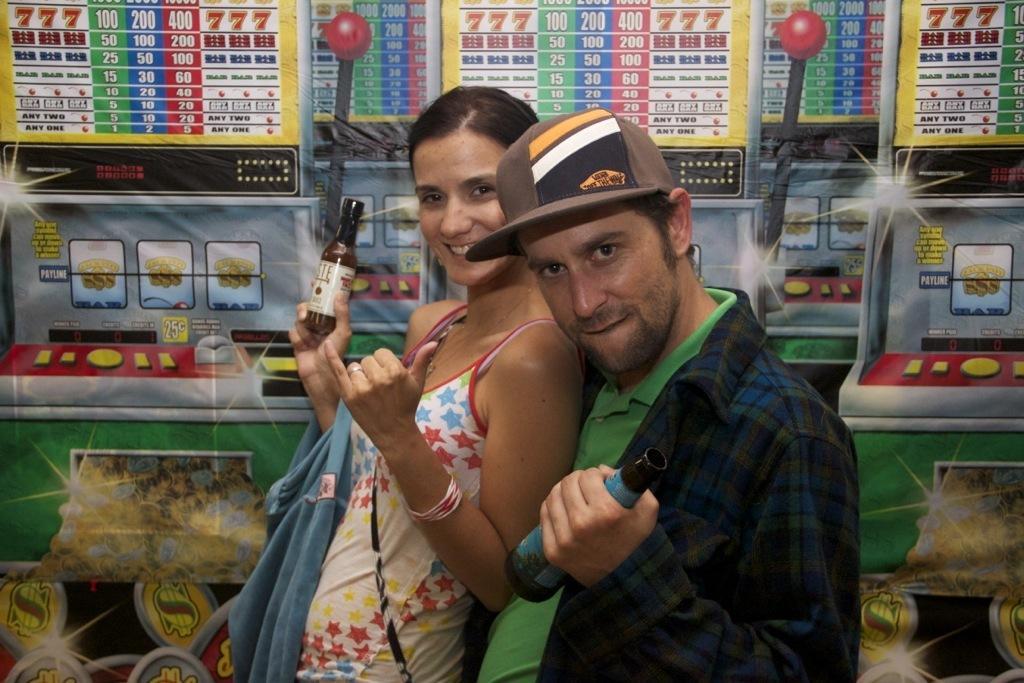Describe this image in one or two sentences. In this image we can see a man and a woman holding bottles. On the backside we can see a some pictures on the wall. 